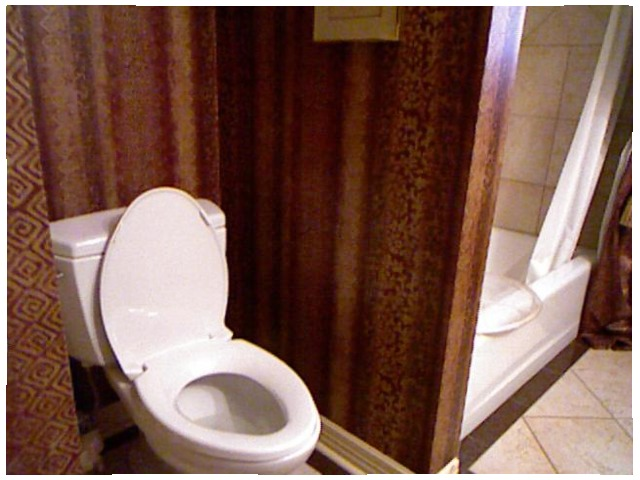<image>
Can you confirm if the toilet is under the shower? No. The toilet is not positioned under the shower. The vertical relationship between these objects is different. Where is the flush tank in relation to the wc? Is it in front of the wc? No. The flush tank is not in front of the wc. The spatial positioning shows a different relationship between these objects. Where is the tub in relation to the wall? Is it behind the wall? Yes. From this viewpoint, the tub is positioned behind the wall, with the wall partially or fully occluding the tub. Is there a baseboard in the floor? No. The baseboard is not contained within the floor. These objects have a different spatial relationship. 